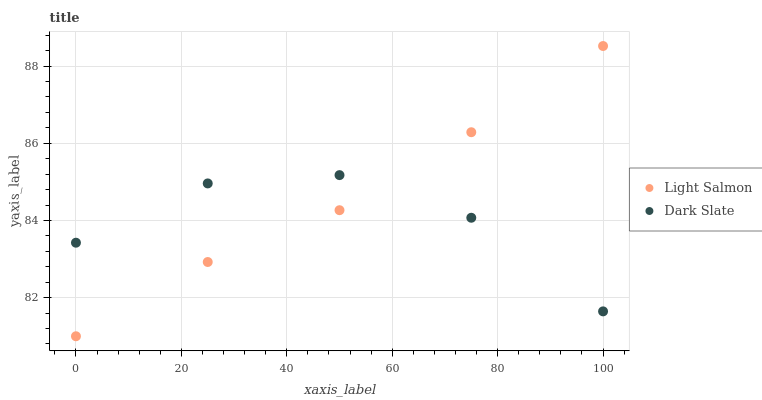Does Dark Slate have the minimum area under the curve?
Answer yes or no. Yes. Does Light Salmon have the maximum area under the curve?
Answer yes or no. Yes. Does Light Salmon have the minimum area under the curve?
Answer yes or no. No. Is Light Salmon the smoothest?
Answer yes or no. Yes. Is Dark Slate the roughest?
Answer yes or no. Yes. Is Light Salmon the roughest?
Answer yes or no. No. Does Light Salmon have the lowest value?
Answer yes or no. Yes. Does Light Salmon have the highest value?
Answer yes or no. Yes. Does Dark Slate intersect Light Salmon?
Answer yes or no. Yes. Is Dark Slate less than Light Salmon?
Answer yes or no. No. Is Dark Slate greater than Light Salmon?
Answer yes or no. No. 